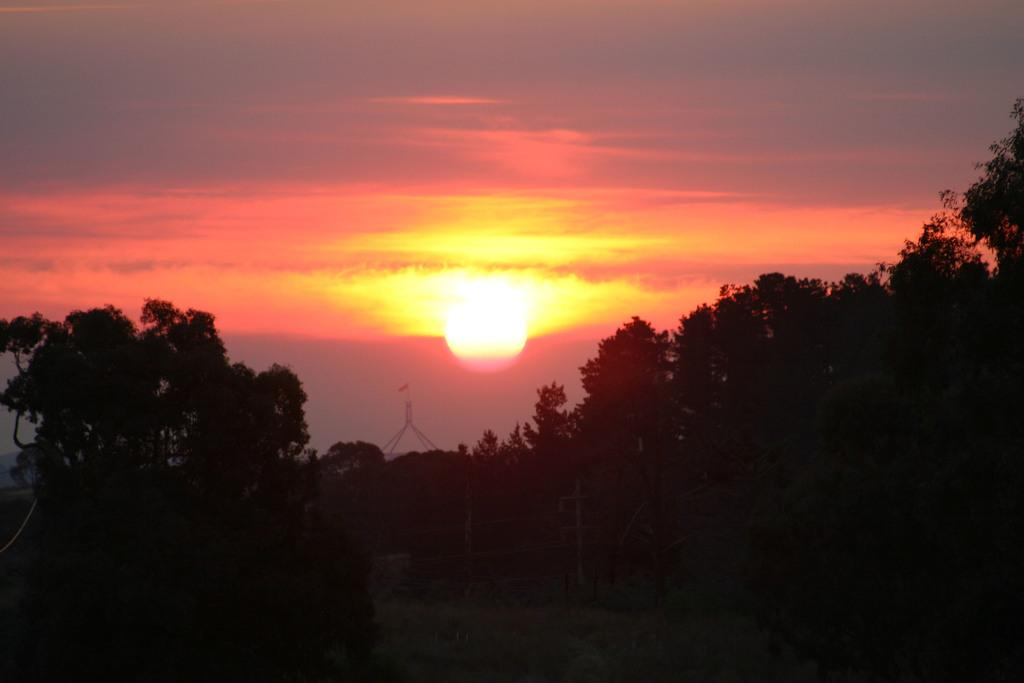What type of vegetation can be seen in the image? There are trees in the image. What material are the poles made of in the image? The poles in the image are made of metal. What is visible in the background of the image? The sky is visible in the background of the image, and there is a flag present. Can the sun be seen in the image? Yes, the sun is observable in the sky. What type of doll is sitting on the linen in the image? There is no doll or linen present in the image. What type of crack is visible on the flag in the image? There is no crack visible on the flag in the image. 